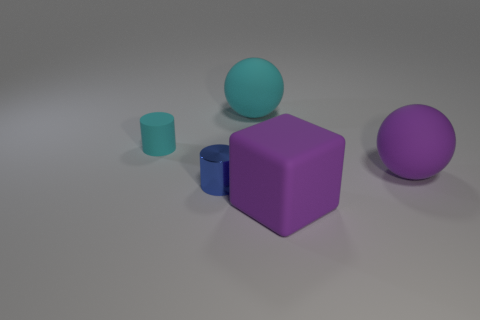Add 2 small blue shiny things. How many objects exist? 7 Subtract 2 cylinders. How many cylinders are left? 0 Add 1 purple matte cubes. How many purple matte cubes are left? 2 Add 2 blue metal cylinders. How many blue metal cylinders exist? 3 Subtract 1 purple cubes. How many objects are left? 4 Subtract all spheres. How many objects are left? 3 Subtract all purple balls. Subtract all purple cylinders. How many balls are left? 1 Subtract all yellow cubes. How many gray cylinders are left? 0 Subtract all tiny red blocks. Subtract all small metal things. How many objects are left? 4 